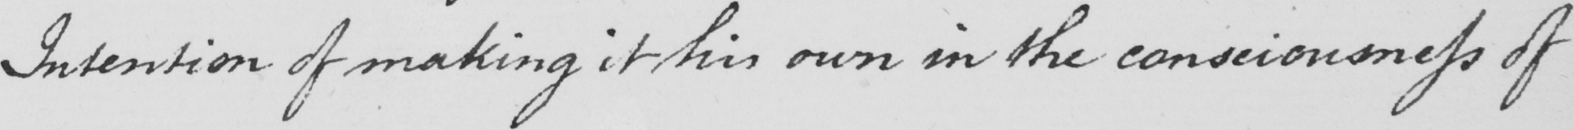Please transcribe the handwritten text in this image. Intention of making it his own in the consciousness of 